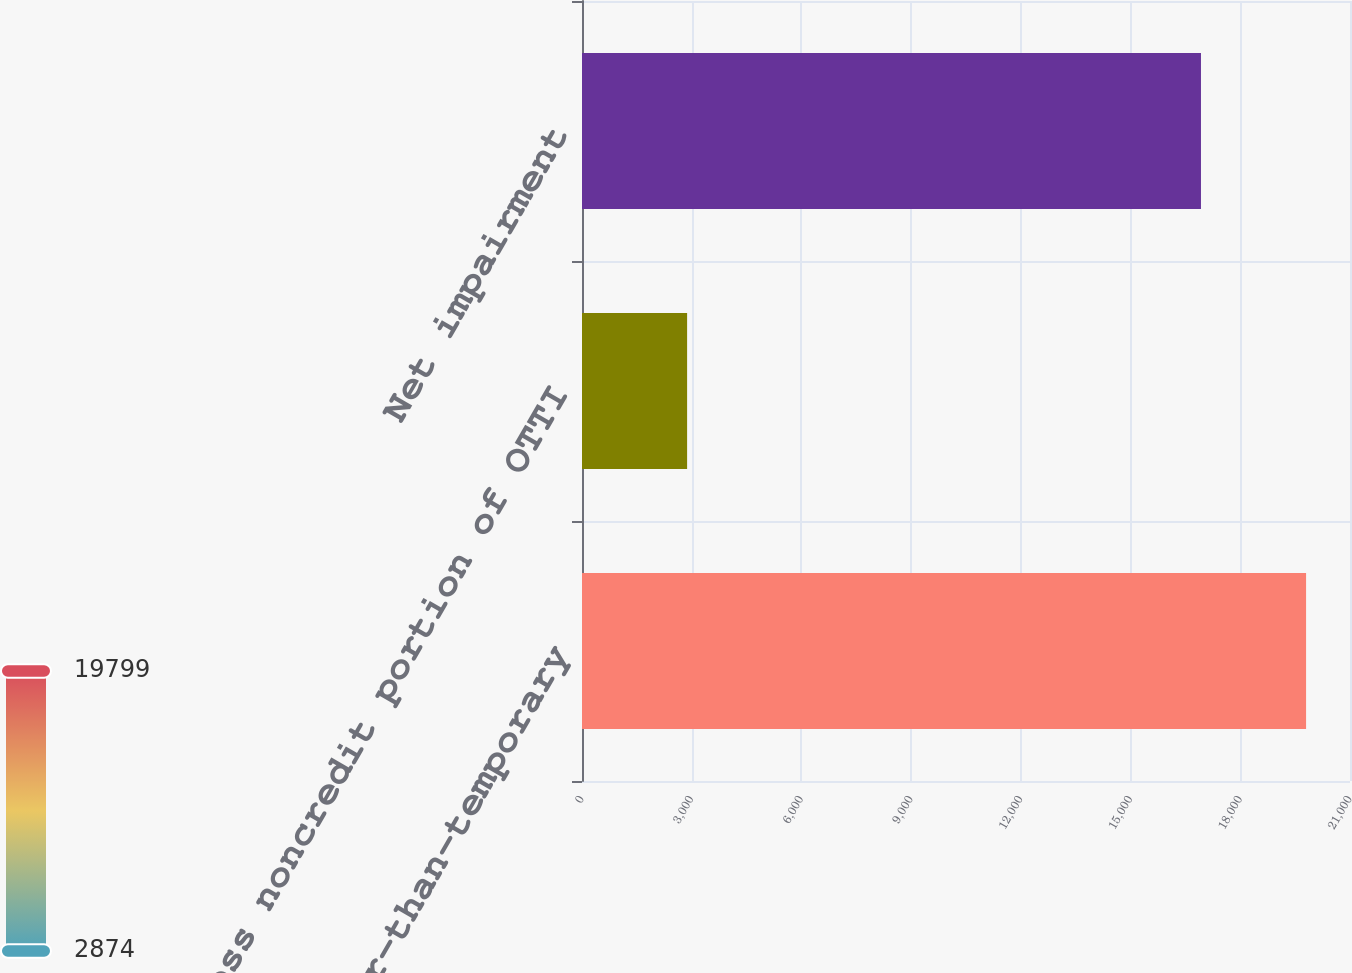Convert chart to OTSL. <chart><loc_0><loc_0><loc_500><loc_500><bar_chart><fcel>Other-than-temporary<fcel>Less noncredit portion of OTTI<fcel>Net impairment<nl><fcel>19799<fcel>2874<fcel>16925<nl></chart> 